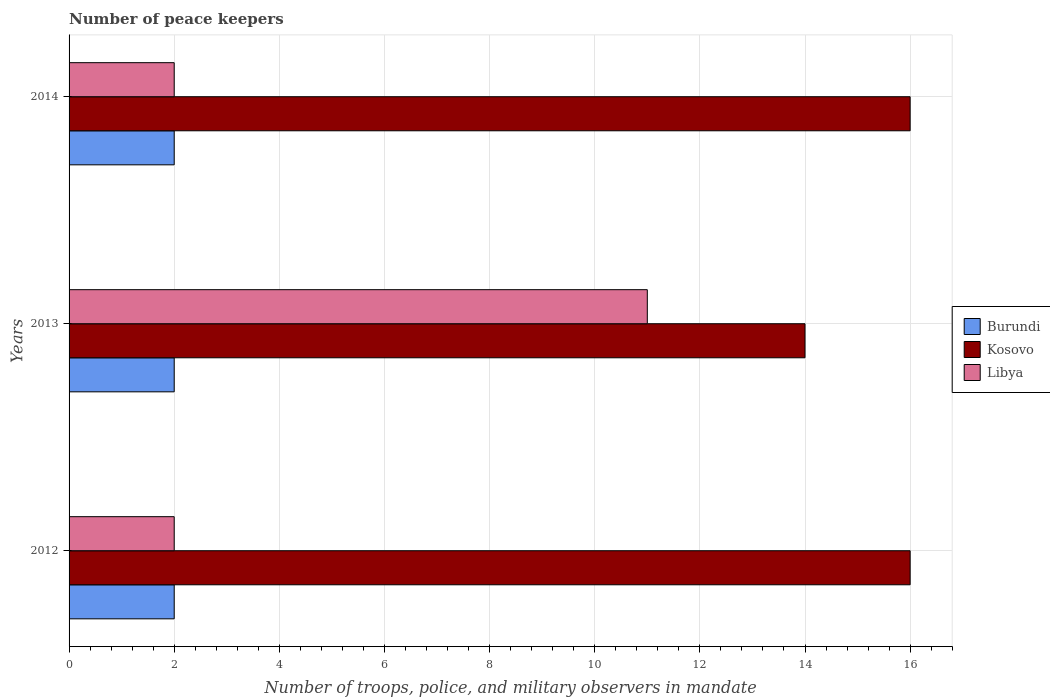How many different coloured bars are there?
Make the answer very short. 3. How many bars are there on the 3rd tick from the bottom?
Your answer should be compact. 3. What is the label of the 1st group of bars from the top?
Keep it short and to the point. 2014. In how many cases, is the number of bars for a given year not equal to the number of legend labels?
Your answer should be compact. 0. In which year was the number of peace keepers in in Libya maximum?
Keep it short and to the point. 2013. In which year was the number of peace keepers in in Burundi minimum?
Give a very brief answer. 2012. What is the difference between the number of peace keepers in in Burundi in 2012 and that in 2013?
Ensure brevity in your answer.  0. What is the difference between the number of peace keepers in in Burundi in 2014 and the number of peace keepers in in Libya in 2012?
Offer a terse response. 0. What is the ratio of the number of peace keepers in in Kosovo in 2012 to that in 2014?
Ensure brevity in your answer.  1. Is the sum of the number of peace keepers in in Kosovo in 2012 and 2014 greater than the maximum number of peace keepers in in Burundi across all years?
Offer a very short reply. Yes. What does the 2nd bar from the top in 2013 represents?
Provide a succinct answer. Kosovo. What does the 1st bar from the bottom in 2012 represents?
Offer a very short reply. Burundi. What is the difference between two consecutive major ticks on the X-axis?
Ensure brevity in your answer.  2. Are the values on the major ticks of X-axis written in scientific E-notation?
Offer a very short reply. No. What is the title of the graph?
Offer a very short reply. Number of peace keepers. What is the label or title of the X-axis?
Ensure brevity in your answer.  Number of troops, police, and military observers in mandate. What is the label or title of the Y-axis?
Keep it short and to the point. Years. What is the Number of troops, police, and military observers in mandate in Libya in 2012?
Provide a short and direct response. 2. What is the Number of troops, police, and military observers in mandate in Burundi in 2013?
Ensure brevity in your answer.  2. What is the Number of troops, police, and military observers in mandate in Libya in 2013?
Make the answer very short. 11. Across all years, what is the maximum Number of troops, police, and military observers in mandate in Burundi?
Give a very brief answer. 2. Across all years, what is the maximum Number of troops, police, and military observers in mandate in Libya?
Your answer should be very brief. 11. Across all years, what is the minimum Number of troops, police, and military observers in mandate of Burundi?
Give a very brief answer. 2. Across all years, what is the minimum Number of troops, police, and military observers in mandate in Kosovo?
Give a very brief answer. 14. What is the difference between the Number of troops, police, and military observers in mandate of Libya in 2012 and that in 2013?
Provide a succinct answer. -9. What is the difference between the Number of troops, police, and military observers in mandate of Burundi in 2012 and that in 2014?
Provide a short and direct response. 0. What is the difference between the Number of troops, police, and military observers in mandate in Burundi in 2013 and that in 2014?
Offer a terse response. 0. What is the difference between the Number of troops, police, and military observers in mandate in Kosovo in 2013 and that in 2014?
Offer a terse response. -2. What is the difference between the Number of troops, police, and military observers in mandate of Libya in 2013 and that in 2014?
Keep it short and to the point. 9. What is the difference between the Number of troops, police, and military observers in mandate in Burundi in 2012 and the Number of troops, police, and military observers in mandate in Kosovo in 2013?
Your response must be concise. -12. What is the difference between the Number of troops, police, and military observers in mandate in Burundi in 2012 and the Number of troops, police, and military observers in mandate in Libya in 2013?
Your response must be concise. -9. What is the difference between the Number of troops, police, and military observers in mandate in Kosovo in 2012 and the Number of troops, police, and military observers in mandate in Libya in 2013?
Your answer should be compact. 5. What is the difference between the Number of troops, police, and military observers in mandate in Burundi in 2012 and the Number of troops, police, and military observers in mandate in Kosovo in 2014?
Offer a very short reply. -14. What is the difference between the Number of troops, police, and military observers in mandate of Kosovo in 2012 and the Number of troops, police, and military observers in mandate of Libya in 2014?
Make the answer very short. 14. What is the average Number of troops, police, and military observers in mandate of Burundi per year?
Ensure brevity in your answer.  2. What is the average Number of troops, police, and military observers in mandate in Kosovo per year?
Your response must be concise. 15.33. What is the average Number of troops, police, and military observers in mandate in Libya per year?
Keep it short and to the point. 5. In the year 2012, what is the difference between the Number of troops, police, and military observers in mandate in Burundi and Number of troops, police, and military observers in mandate in Kosovo?
Offer a very short reply. -14. In the year 2012, what is the difference between the Number of troops, police, and military observers in mandate in Burundi and Number of troops, police, and military observers in mandate in Libya?
Offer a very short reply. 0. In the year 2014, what is the difference between the Number of troops, police, and military observers in mandate of Burundi and Number of troops, police, and military observers in mandate of Kosovo?
Your answer should be compact. -14. In the year 2014, what is the difference between the Number of troops, police, and military observers in mandate in Kosovo and Number of troops, police, and military observers in mandate in Libya?
Provide a short and direct response. 14. What is the ratio of the Number of troops, police, and military observers in mandate in Kosovo in 2012 to that in 2013?
Keep it short and to the point. 1.14. What is the ratio of the Number of troops, police, and military observers in mandate in Libya in 2012 to that in 2013?
Offer a terse response. 0.18. What is the ratio of the Number of troops, police, and military observers in mandate of Burundi in 2012 to that in 2014?
Your response must be concise. 1. What is the ratio of the Number of troops, police, and military observers in mandate of Kosovo in 2012 to that in 2014?
Make the answer very short. 1. What is the difference between the highest and the second highest Number of troops, police, and military observers in mandate in Burundi?
Offer a terse response. 0. What is the difference between the highest and the second highest Number of troops, police, and military observers in mandate of Kosovo?
Your answer should be compact. 0. What is the difference between the highest and the lowest Number of troops, police, and military observers in mandate of Burundi?
Your response must be concise. 0. What is the difference between the highest and the lowest Number of troops, police, and military observers in mandate in Kosovo?
Your answer should be compact. 2. What is the difference between the highest and the lowest Number of troops, police, and military observers in mandate in Libya?
Your answer should be compact. 9. 